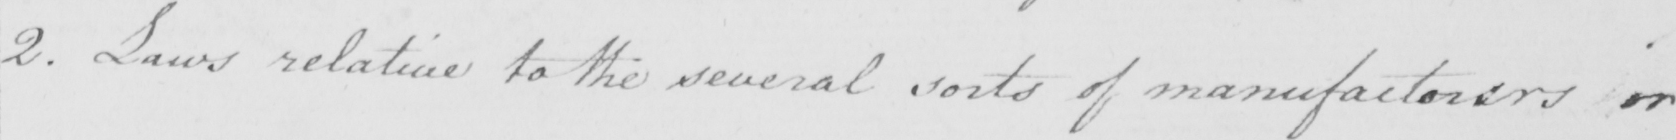What does this handwritten line say? 2 . Laws relative to the several sorts of manufacturers or 